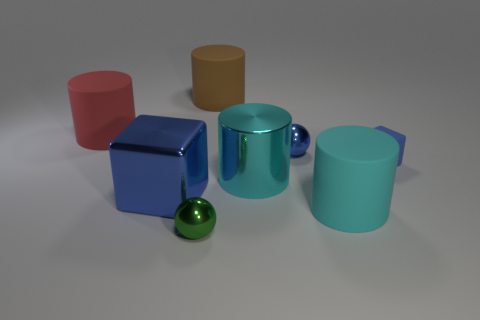Can you describe the lighting and shadows in the image? The image has diffuse, overhead lighting that creates soft shadows beneath and to the sides of the objects, suggesting an indoor environment with a single, broad light source. The smoothness and direction of the shadows help to reveal the shape and texture of each object. 